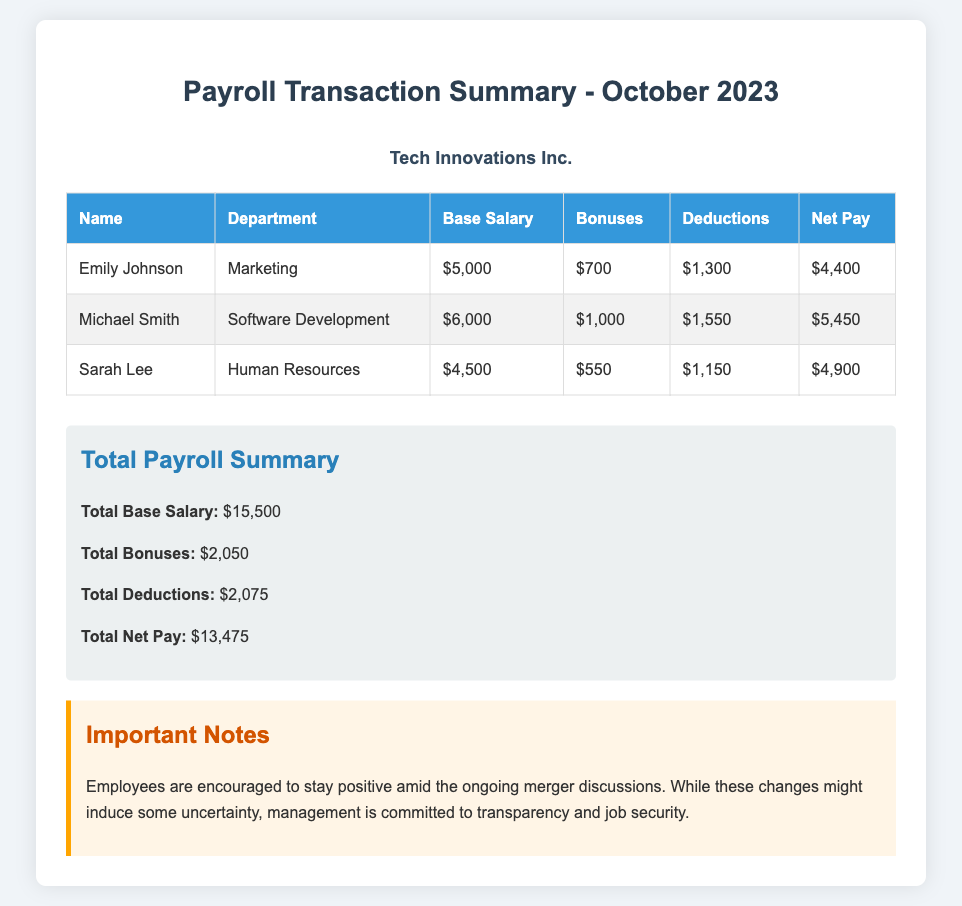What is the total base salary? The total base salary is the sum of the base salaries of all employees listed in the document, which is $5,000 + $6,000 + $4,500 = $15,500.
Answer: $15,500 Who is the employee with the highest net pay? The employee with the highest net pay is the one with the highest net pay value listed in the document, which is Michael Smith with $5,450.
Answer: Michael Smith What is Sarah Lee's department? Sarah Lee's department is listed in the document, which is Human Resources.
Answer: Human Resources How much is total deductions? The total deductions is the sum of all deductions for the employees, stated in the document as $1,300 + $1,550 + $1,150 = $2,075.
Answer: $2,075 What is Emily Johnson's bonus? Emily Johnson's bonus is specifically mentioned in the document, which is $700.
Answer: $700 What is the total net pay? The total net pay is the sum of all net pay amounts for the employees listed, calculated as $4,400 + $5,450 + $4,900 = $13,475.
Answer: $13,475 What are the important notes about the merger? The important notes reflect management's dedication to transparency and job security amid merger uncertainties.
Answer: Transparency and job security How much bonus did Michael Smith receive? Michael Smith's bonus is explicitly stated in the document, which is $1,000.
Answer: $1,000 What is the total bonus amount for all employees? The total bonus amount is the accumulation of all bonuses indicated in the document: $700 + $1,000 + $550 = $2,050.
Answer: $2,050 